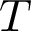Convert formula to latex. <formula><loc_0><loc_0><loc_500><loc_500>T</formula> 